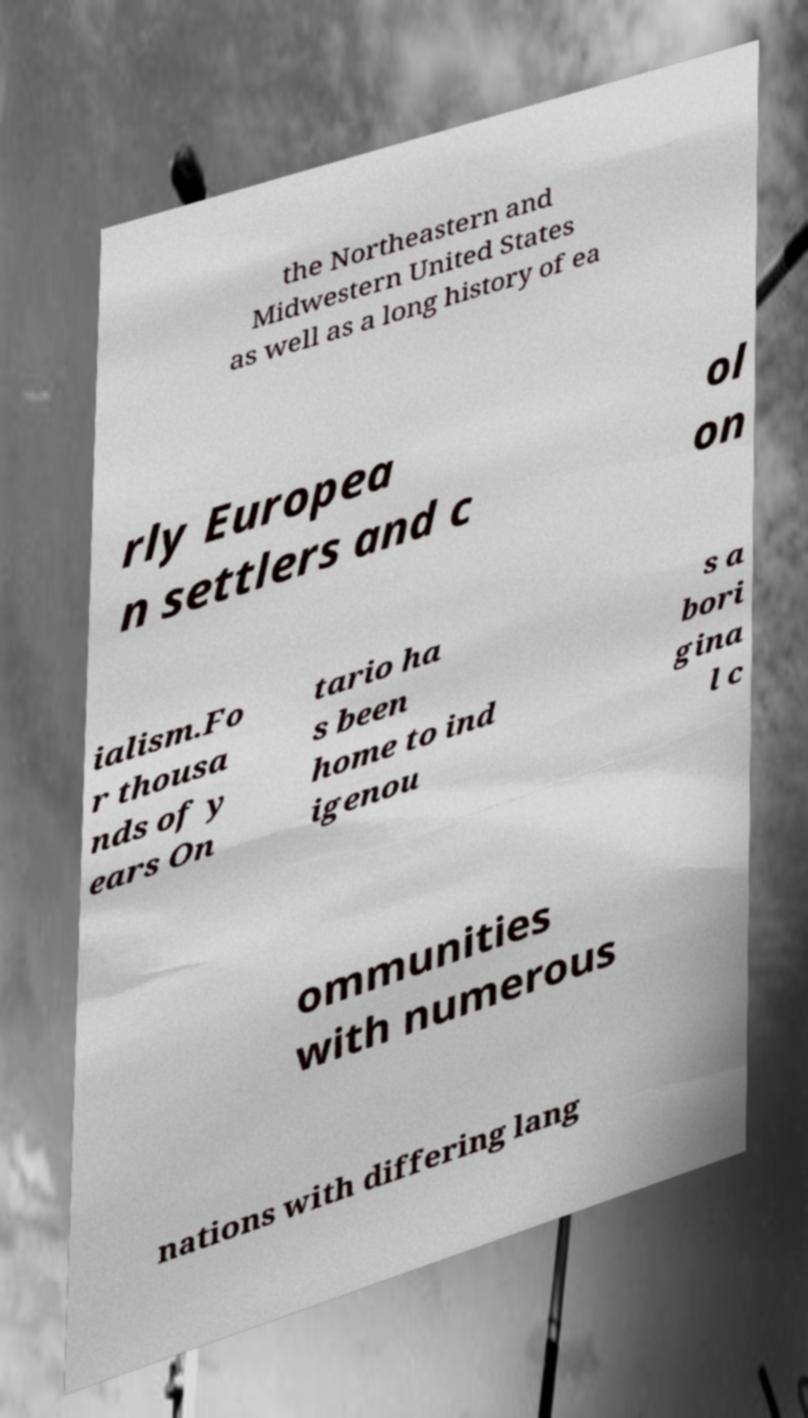Could you assist in decoding the text presented in this image and type it out clearly? the Northeastern and Midwestern United States as well as a long history of ea rly Europea n settlers and c ol on ialism.Fo r thousa nds of y ears On tario ha s been home to ind igenou s a bori gina l c ommunities with numerous nations with differing lang 